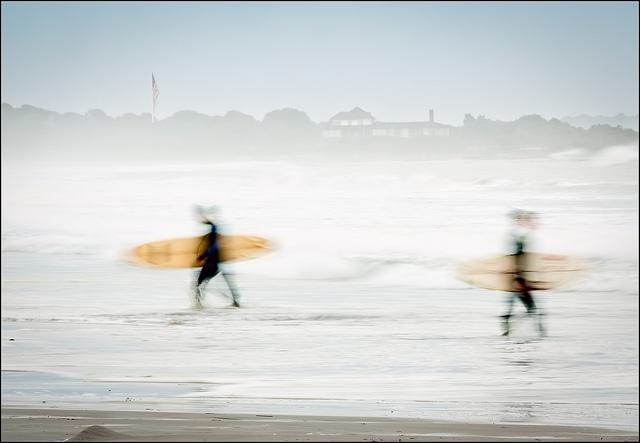How many blurry figures are passing the ocean with a surfboard in their hands? Please explain your reasoning. two. One can make out a pair of humanoid figures carrying surfboards. 